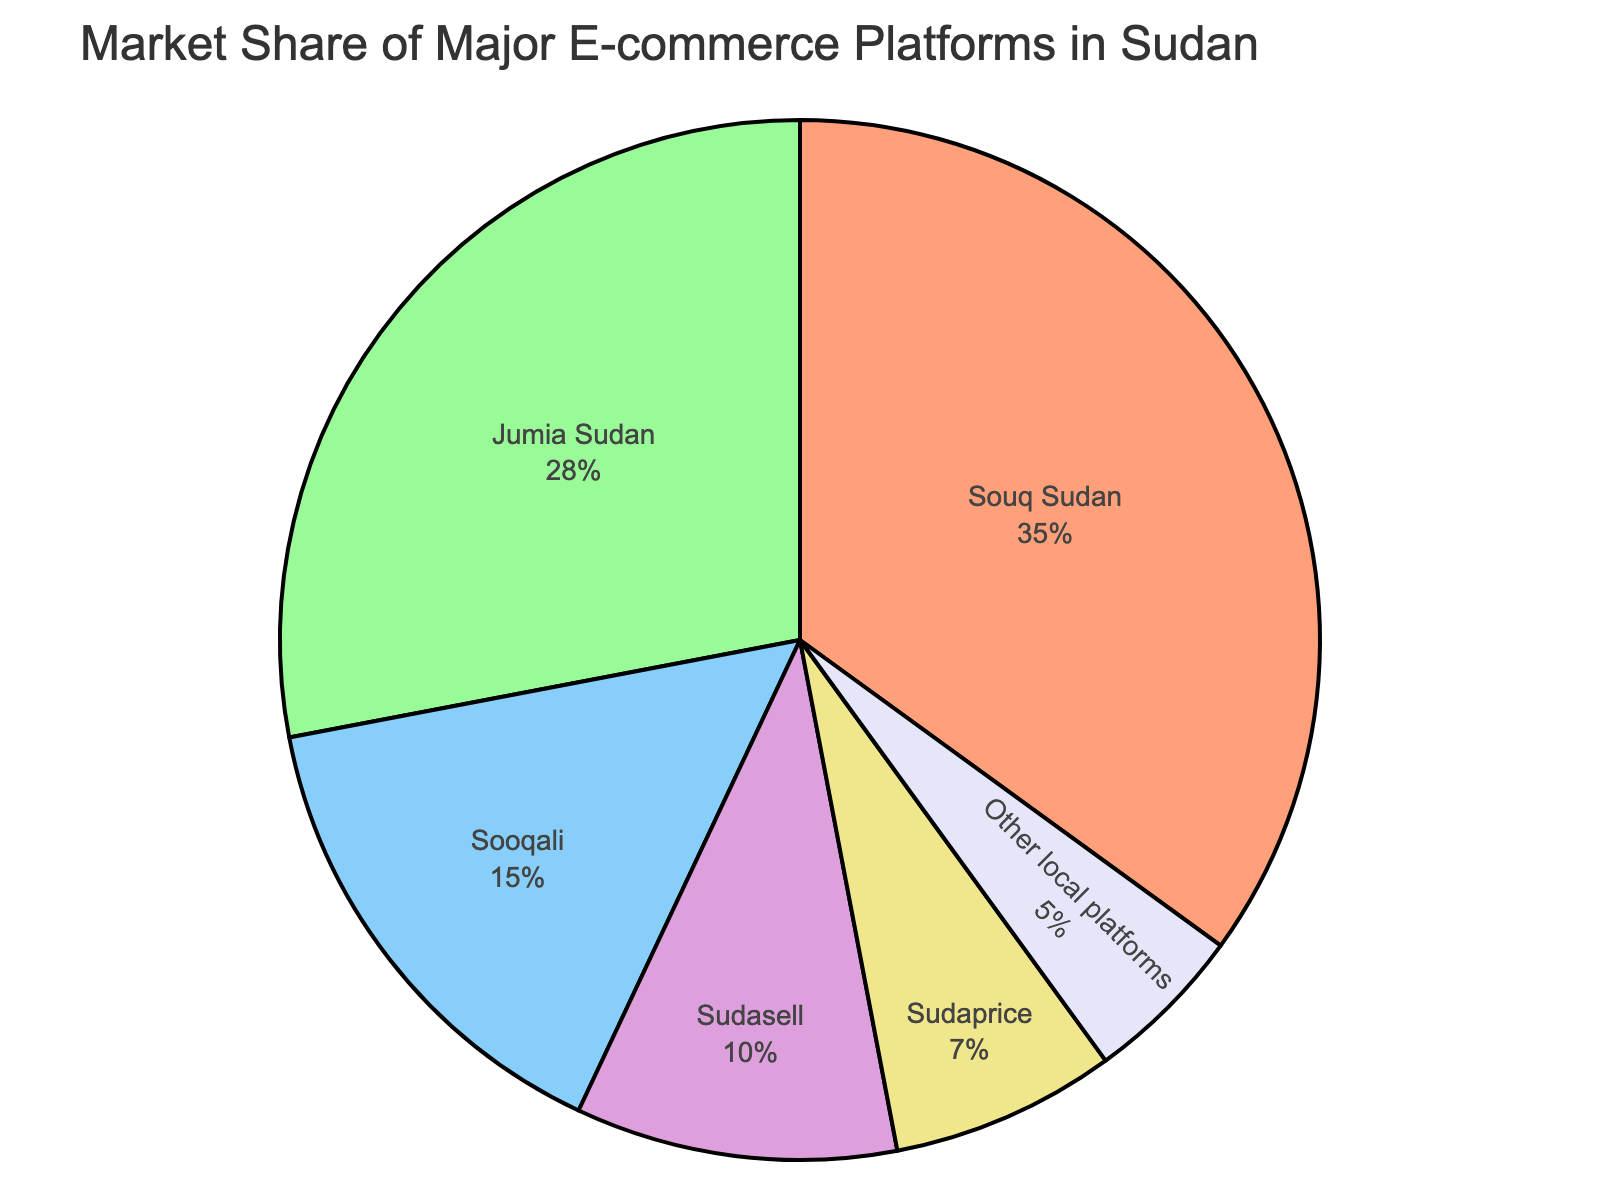What is the market share of Souq Sudan? The figure shows a pie chart with different segments representing various platforms. Souq Sudan is labelled with its market share percentage.
Answer: 35% Which platform holds the second largest market share? By inspecting the pie chart, the segments can be compared by size. The second largest segment after Souq Sudan is Jumia Sudan.
Answer: Jumia Sudan What is the combined market share of Sooqali and Other local platforms? The figure displays the market shares for each platform. Adding the market shares for Sooqali (15%) and Other local platforms (5%) will give the combined value. 15 + 5 = 20
Answer: 20% How does Jumia Sudan's market share compare to Sudasell's? The respective market shares can be directly compared. Jumia Sudan has 28% and Sudasell has 10%. Since 28% is greater than 10%, Jumia Sudan's share is larger.
Answer: Jumia Sudan has a larger market share What is the difference in market share between the largest and smallest platforms? The figure shows Souq Sudan with the largest share at 35%, and Other local platforms with the smallest at 5%. The difference is calculated as 35 - 5 = 30.
Answer: 30% Which segment is colored red? By examining the color code in the pie chart, the red segment corresponds to Souq Sudan.
Answer: Souq Sudan What percentage of the market is captured by platforms other than Souq Sudan and Jumia Sudan? Adding the market shares of platforms other than Souq Sudan (35%) and Jumia Sudan (28%) involves Sooqali (15%), Sudasell (10%), Sudaprice (7%), and Other local platforms (5%). Summing these values: 15 + 10 + 7 + 5 = 37
Answer: 37% If the market share of Jumia Sudan increases by 7%, what will its new market share be? The current market share of Jumia Sudan is 28%. Adding an increase of 7% results in 28 + 7 = 35
Answer: 35% What is the total market share of Sudasell and Sudaprice combined? From the pie chart, Sudasell has 10% and Sudaprice has 7%. Adding these values results in 10 + 7 = 17.
Answer: 17% Among Sudasell, Sudaprice, and Other local platforms, which one has the smallest market share? Comparing the three segments, Sudasell has 10%, Sudaprice has 7%, and Other local platforms have 5%. The smallest amongst them is Other local platforms.
Answer: Other local platforms 